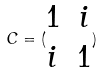Convert formula to latex. <formula><loc_0><loc_0><loc_500><loc_500>C = ( \begin{matrix} 1 & i \\ i & 1 \end{matrix} )</formula> 